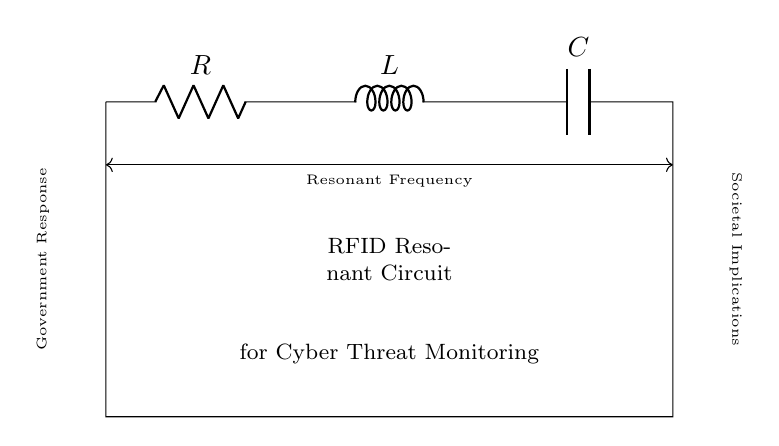What are the components of this circuit? The circuit consists of three main components: a resistor, an inductor, and a capacitor, which are connected in series. This can be identified by the symbols and labels R, L, and C in the diagram.
Answer: Resistor, Inductor, Capacitor What is the main application of this resonant circuit? The diagram indicates that the main application of the resonant circuit is related to RFID technology for tracking and monitoring potential cyber threats, as described in the annotations.
Answer: Cyber Threat Monitoring What does the line labeled "Resonant Frequency" indicate? The line labeled "Resonant Frequency" signifies the frequency at which the circuit resonates due to the interplay of resistance, inductance, and capacitance. This understanding comes from the fact that the resonant frequency is a key characteristic of RLC circuits.
Answer: Resonant Frequency How does this circuit impact societal implications? The circuit’s function in monitoring and tracking potential cyber threats can lead to significant societal implications, such as privacy concerns and government surveillance, as indicated by the annotation pointing towards "Societal Implications."
Answer: Surveillance Implications What role does the antenna play in this circuit? The antenna in this circuit is utilized to transmit or receive radio frequency signals, allowing the RFID technology to function effectively. This is indicated by the connection to the antenna component within the diagram.
Answer: Signal Transmission What is the relationship between government response and this circuit? The diagram depicts a connection between government responses to cyber threats and the operational functionality of the resonant circuit, signifying that governmental actions may influence the use of technology in RFID applications.
Answer: Government Actions 